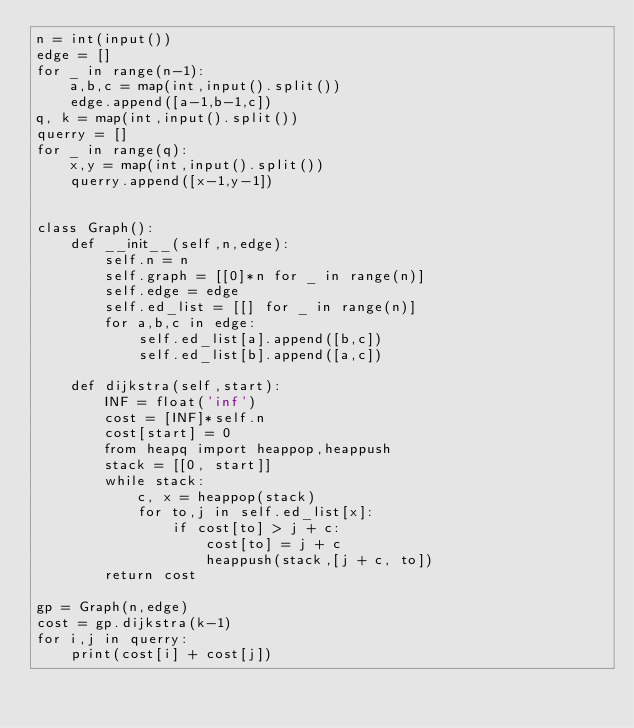Convert code to text. <code><loc_0><loc_0><loc_500><loc_500><_Python_>n = int(input())
edge = []
for _ in range(n-1):
    a,b,c = map(int,input().split())
    edge.append([a-1,b-1,c])
q, k = map(int,input().split())
querry = []
for _ in range(q):
    x,y = map(int,input().split())
    querry.append([x-1,y-1])
    

class Graph():
    def __init__(self,n,edge):
        self.n = n
        self.graph = [[0]*n for _ in range(n)]
        self.edge = edge
        self.ed_list = [[] for _ in range(n)]
        for a,b,c in edge:
            self.ed_list[a].append([b,c])
            self.ed_list[b].append([a,c])
    
    def dijkstra(self,start):
        INF = float('inf')
        cost = [INF]*self.n
        cost[start] = 0
        from heapq import heappop,heappush
        stack = [[0, start]]
        while stack:
            c, x = heappop(stack)
            for to,j in self.ed_list[x]:
                if cost[to] > j + c:
                    cost[to] = j + c
                    heappush(stack,[j + c, to])
        return cost

gp = Graph(n,edge)
cost = gp.dijkstra(k-1)
for i,j in querry:
    print(cost[i] + cost[j])

</code> 